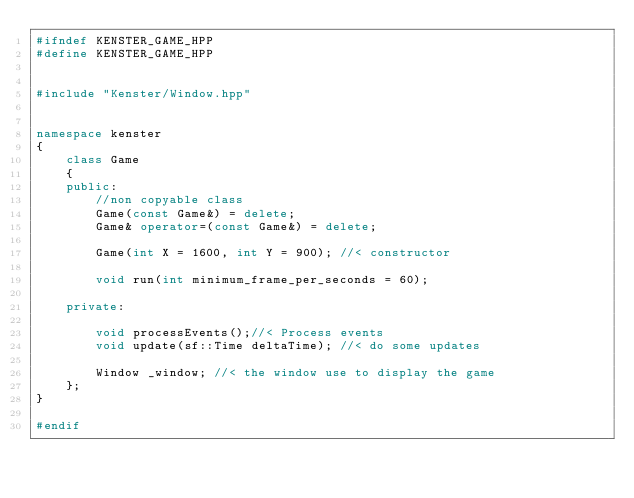<code> <loc_0><loc_0><loc_500><loc_500><_C++_>#ifndef KENSTER_GAME_HPP
#define KENSTER_GAME_HPP


#include "Kenster/Window.hpp"


namespace kenster
{
	class Game
	{
	public:
		//non copyable class
		Game(const Game&) = delete;
		Game& operator=(const Game&) = delete;

		Game(int X = 1600, int Y = 900); //< constructor

		void run(int minimum_frame_per_seconds = 60);

	private:

		void processEvents();//< Process events
		void update(sf::Time deltaTime); //< do some updates

		Window _window; //< the window use to display the game
	};
}

#endif

</code> 